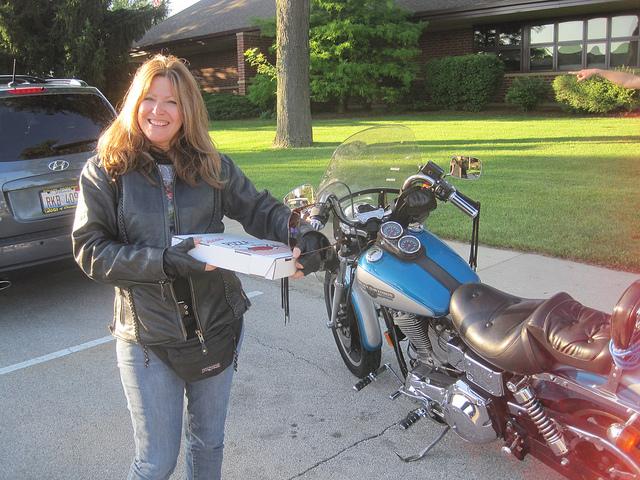Is the woman smiling at the camera?
Keep it brief. Yes. What's for dinner?
Quick response, please. Pizza. Is she eating doughnuts?
Answer briefly. No. 